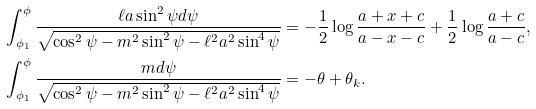Convert formula to latex. <formula><loc_0><loc_0><loc_500><loc_500>& \int _ { \phi _ { 1 } } ^ { \phi } \frac { \ell a \sin ^ { 2 } \psi d \psi } { \sqrt { \cos ^ { 2 } \psi - m ^ { 2 } \sin ^ { 2 } \psi - \ell ^ { 2 } a ^ { 2 } \sin ^ { 4 } \psi } } = - \frac { 1 } { 2 } \log \frac { a + x + c } { a - x - c } + \frac { 1 } { 2 } \log \frac { a + c } { a - c } , \\ & \int _ { \phi _ { 1 } } ^ { \phi } \frac { m d \psi } { \sqrt { \cos ^ { 2 } \psi - m ^ { 2 } \sin ^ { 2 } \psi - \ell ^ { 2 } a ^ { 2 } \sin ^ { 4 } \psi } } = - \theta + \theta _ { k } .</formula> 